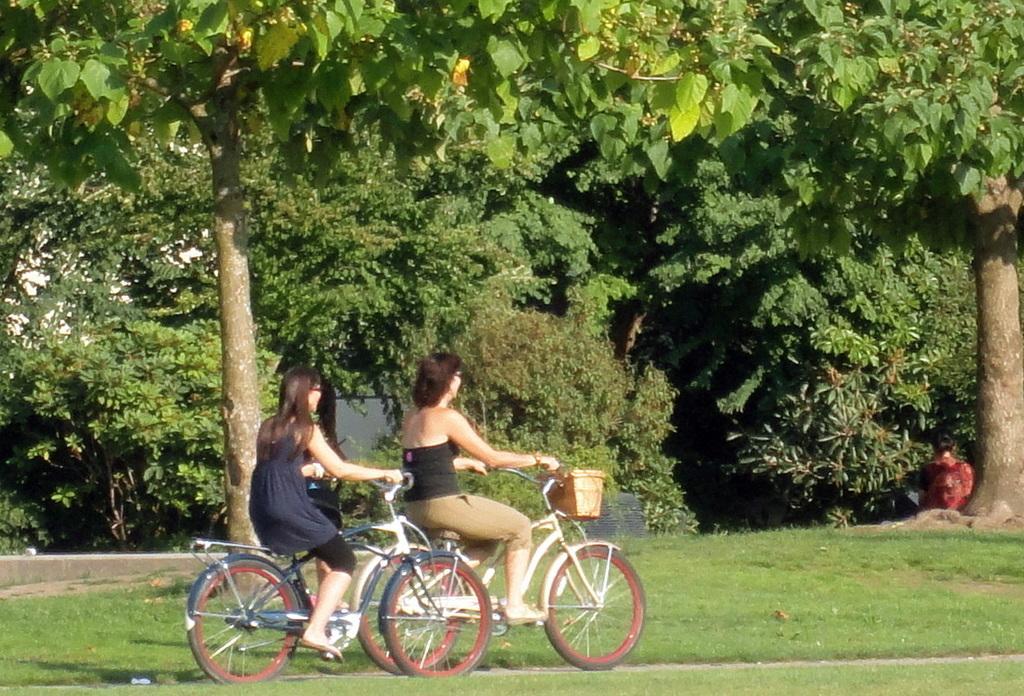Please provide a concise description of this image. In this picture we can see two women riding bicycles on a fresh green grass. These are trees. 